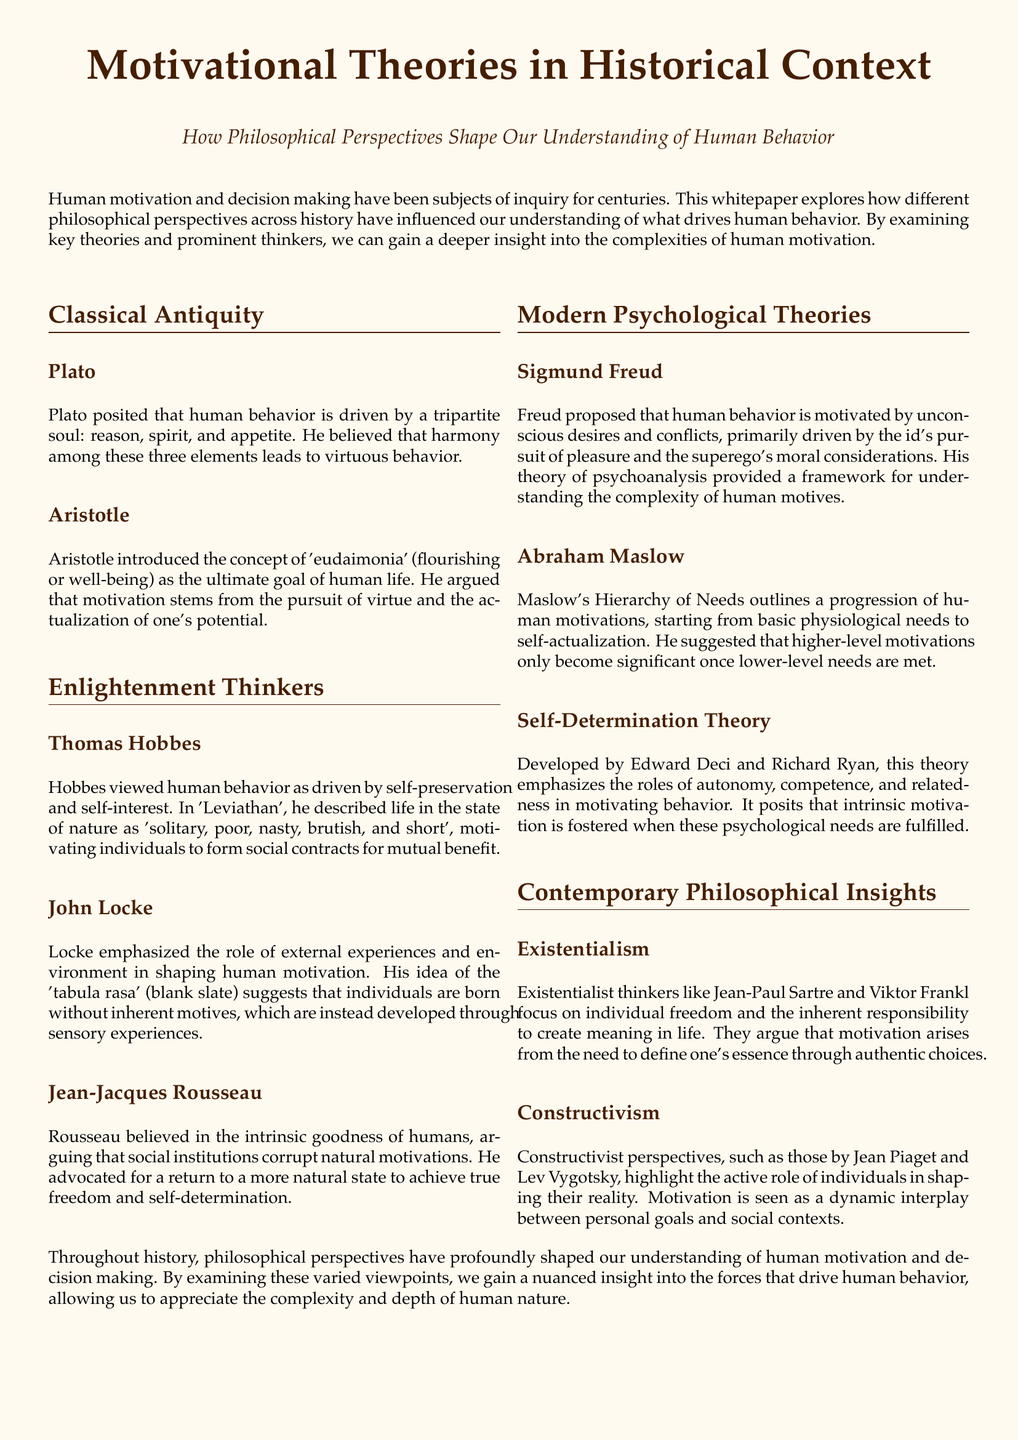What is the title of the whitepaper? The title of the whitepaper is indicated prominently at the top of the document.
Answer: Motivational Theories in Historical Context Who introduced the concept of 'eudaimonia'? This information is found in the section on Classical Antiquity, specifically under Aristotle.
Answer: Aristotle What does Plato believe leads to virtuous behavior? Plato's view is mentioned in his section, where he discusses the tripartite soul's harmony.
Answer: Harmony among reason, spirit, and appetite According to Maslow, what is the first level of needs? The first level in Maslow's Hierarchy of Needs is outlined in his section discussing human motivations.
Answer: Physiological needs What philosophical perspective does Jean-Paul Sartre represent? The document identifies Sartre with a specific philosophical movement in the Contemporary Philosophical Insights section.
Answer: Existentialism How many main elements does Plato's tripartite soul have? The number of elements is stated directly in the section about Plato.
Answer: Three What does Self-Determination Theory emphasize as key in motivating behavior? This is found in the description of the Self-Determination Theory section.
Answer: Autonomy, competence, and relatedness Who is the author of the concept of the 'blank slate'? The document specifies this author under the Enlightenment Thinkers section.
Answer: John Locke 